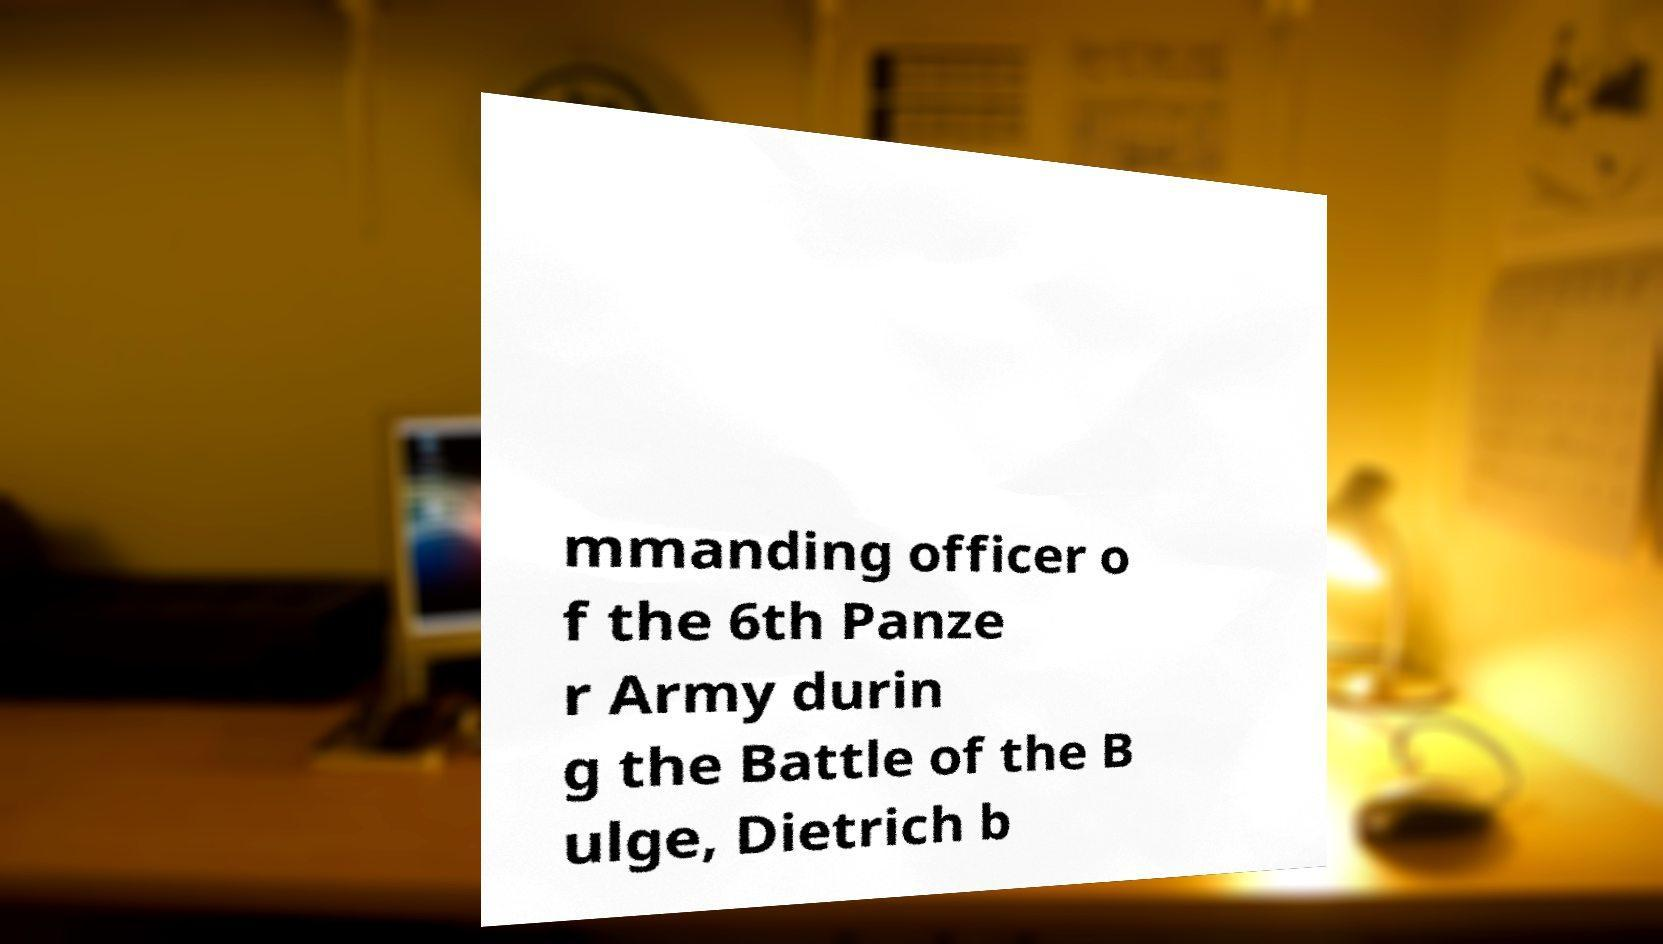Could you extract and type out the text from this image? mmanding officer o f the 6th Panze r Army durin g the Battle of the B ulge, Dietrich b 